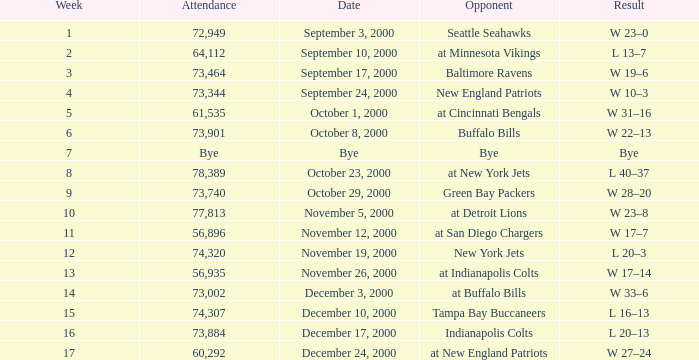What is the Result of the game with 72,949 in attendance? W 23–0. 